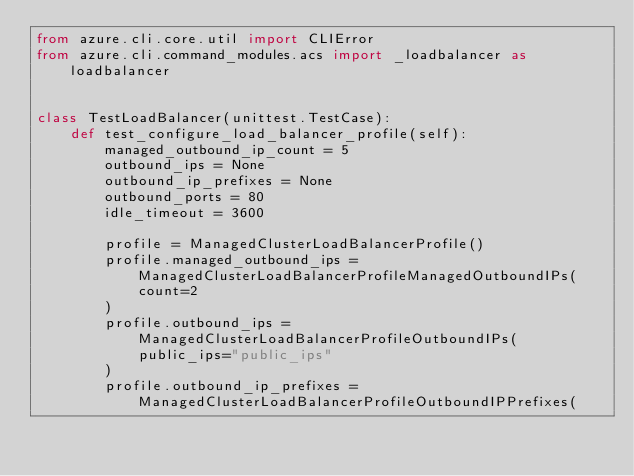<code> <loc_0><loc_0><loc_500><loc_500><_Python_>from azure.cli.core.util import CLIError
from azure.cli.command_modules.acs import _loadbalancer as loadbalancer


class TestLoadBalancer(unittest.TestCase):
    def test_configure_load_balancer_profile(self):
        managed_outbound_ip_count = 5
        outbound_ips = None
        outbound_ip_prefixes = None
        outbound_ports = 80
        idle_timeout = 3600

        profile = ManagedClusterLoadBalancerProfile()
        profile.managed_outbound_ips = ManagedClusterLoadBalancerProfileManagedOutboundIPs(
            count=2
        )
        profile.outbound_ips = ManagedClusterLoadBalancerProfileOutboundIPs(
            public_ips="public_ips"
        )
        profile.outbound_ip_prefixes = ManagedClusterLoadBalancerProfileOutboundIPPrefixes(</code> 